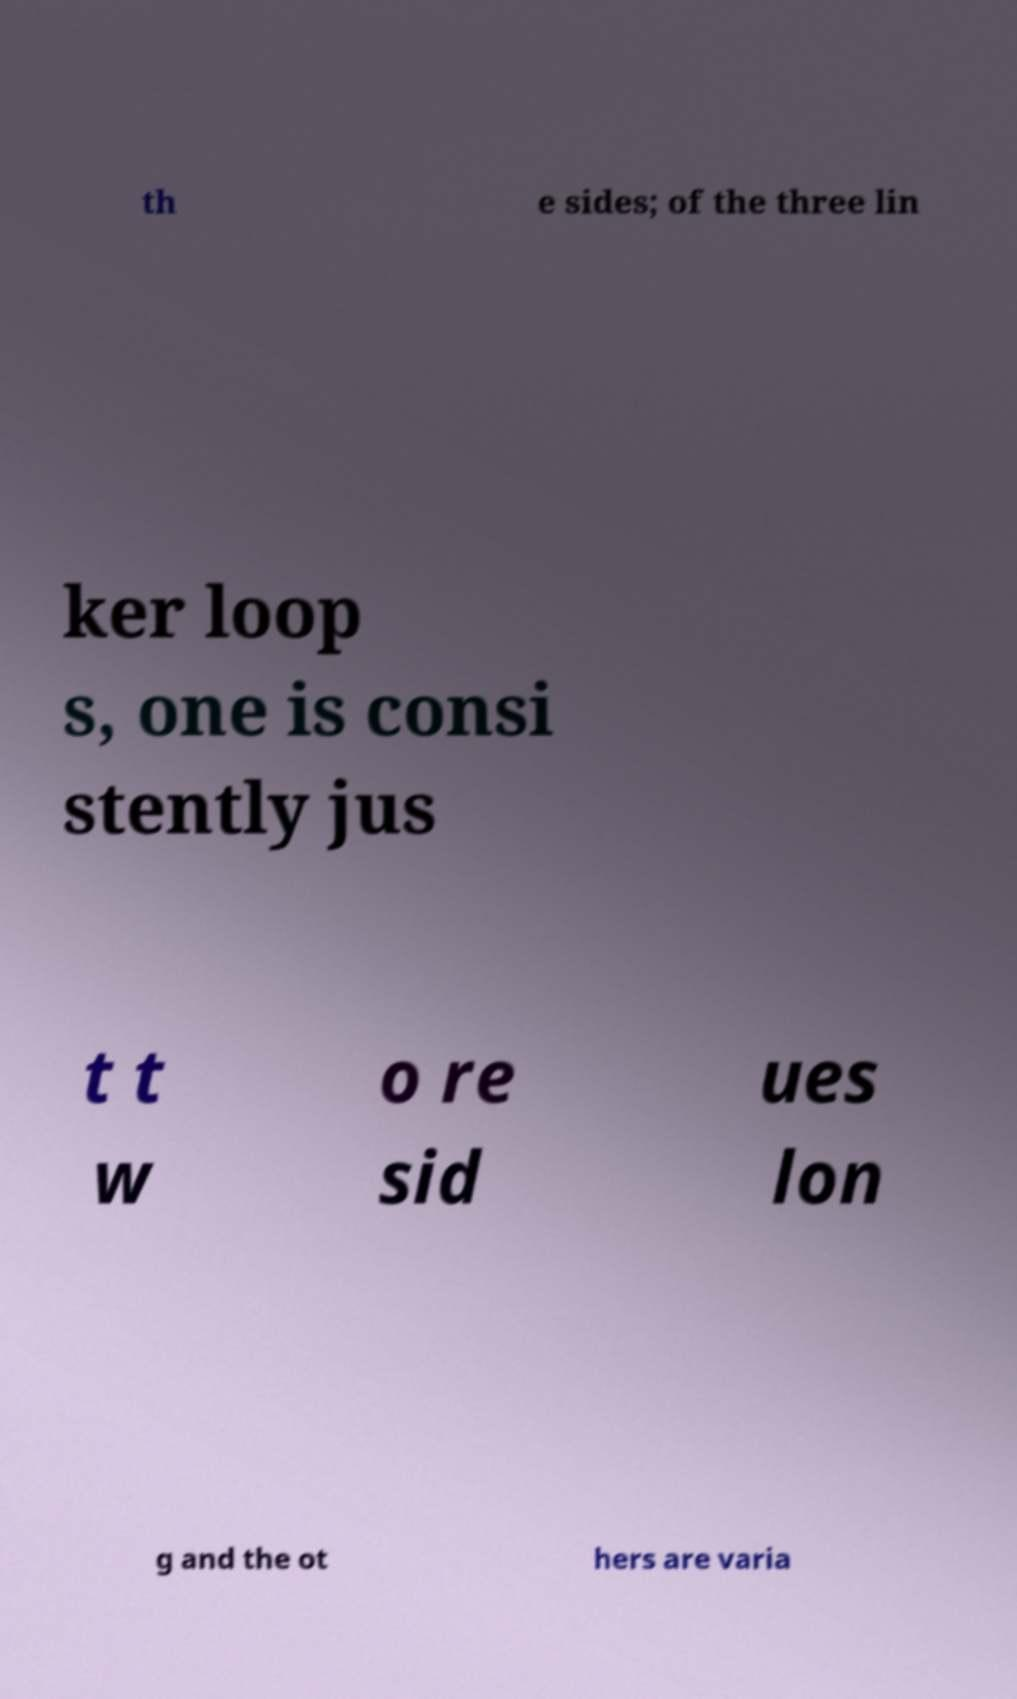What messages or text are displayed in this image? I need them in a readable, typed format. th e sides; of the three lin ker loop s, one is consi stently jus t t w o re sid ues lon g and the ot hers are varia 